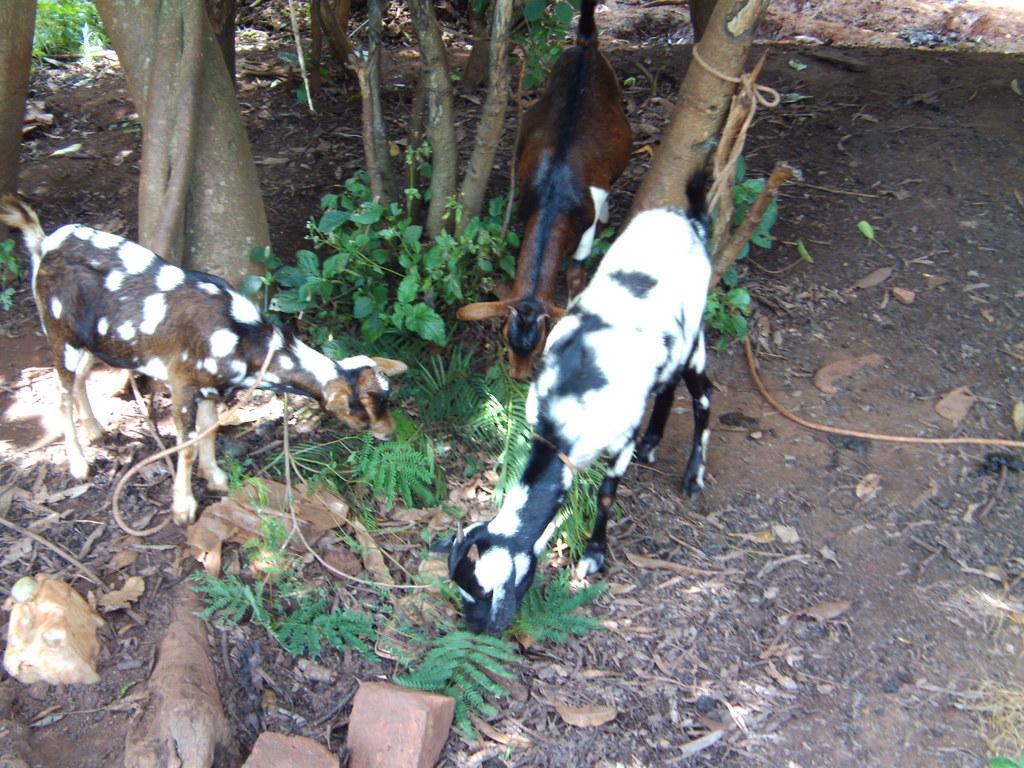In one or two sentences, can you explain what this image depicts? This image consists of three goats. At the bottom, we can see the rocks and dried leaves on the ground. In the middle, there are plants. In the background, there are trees. 